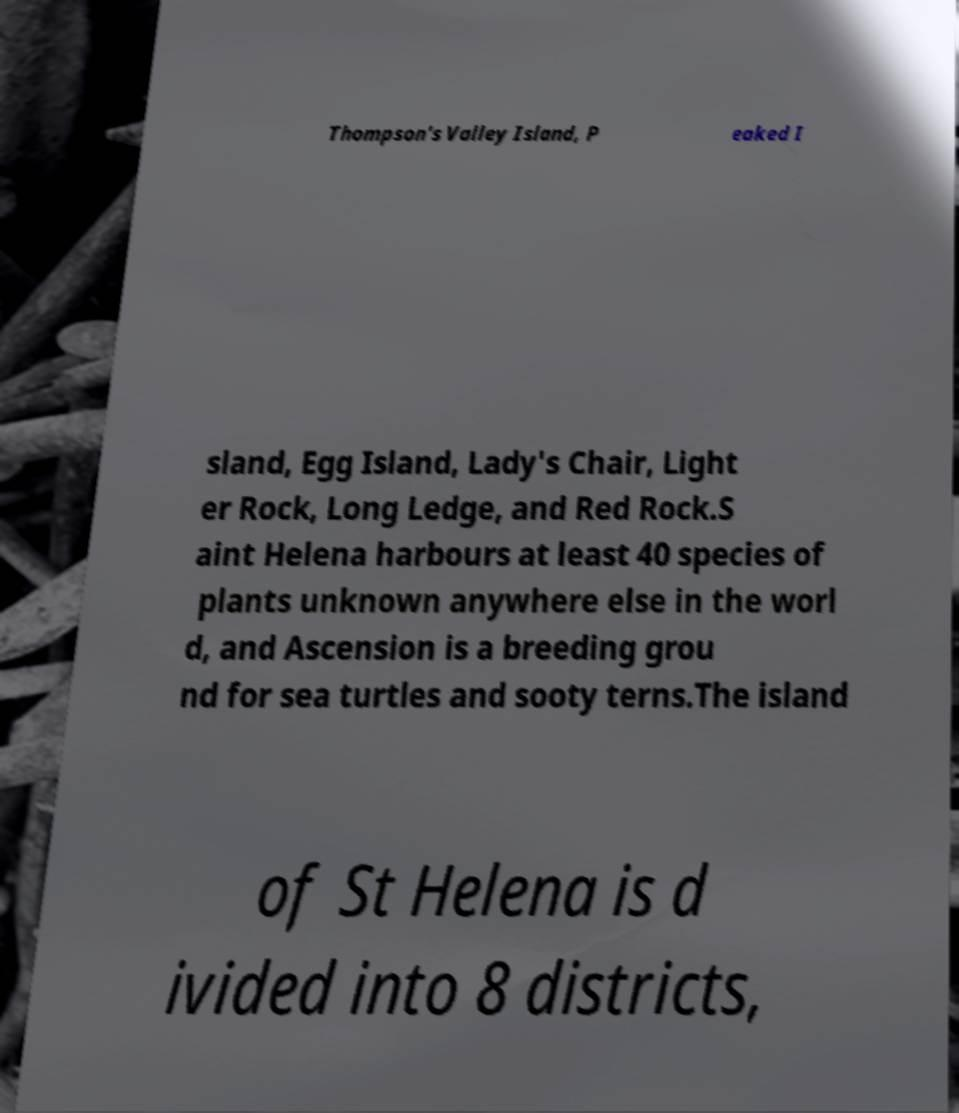Could you extract and type out the text from this image? Thompson's Valley Island, P eaked I sland, Egg Island, Lady's Chair, Light er Rock, Long Ledge, and Red Rock.S aint Helena harbours at least 40 species of plants unknown anywhere else in the worl d, and Ascension is a breeding grou nd for sea turtles and sooty terns.The island of St Helena is d ivided into 8 districts, 